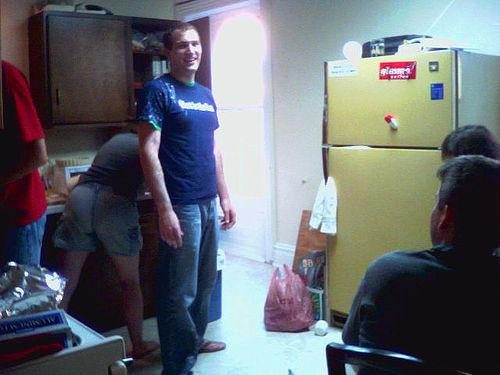Where is this?
Answer briefly. Kitchen. What color is the man's shirt?
Quick response, please. Blue. Is there anything on the refrigerator?
Concise answer only. Yes. 